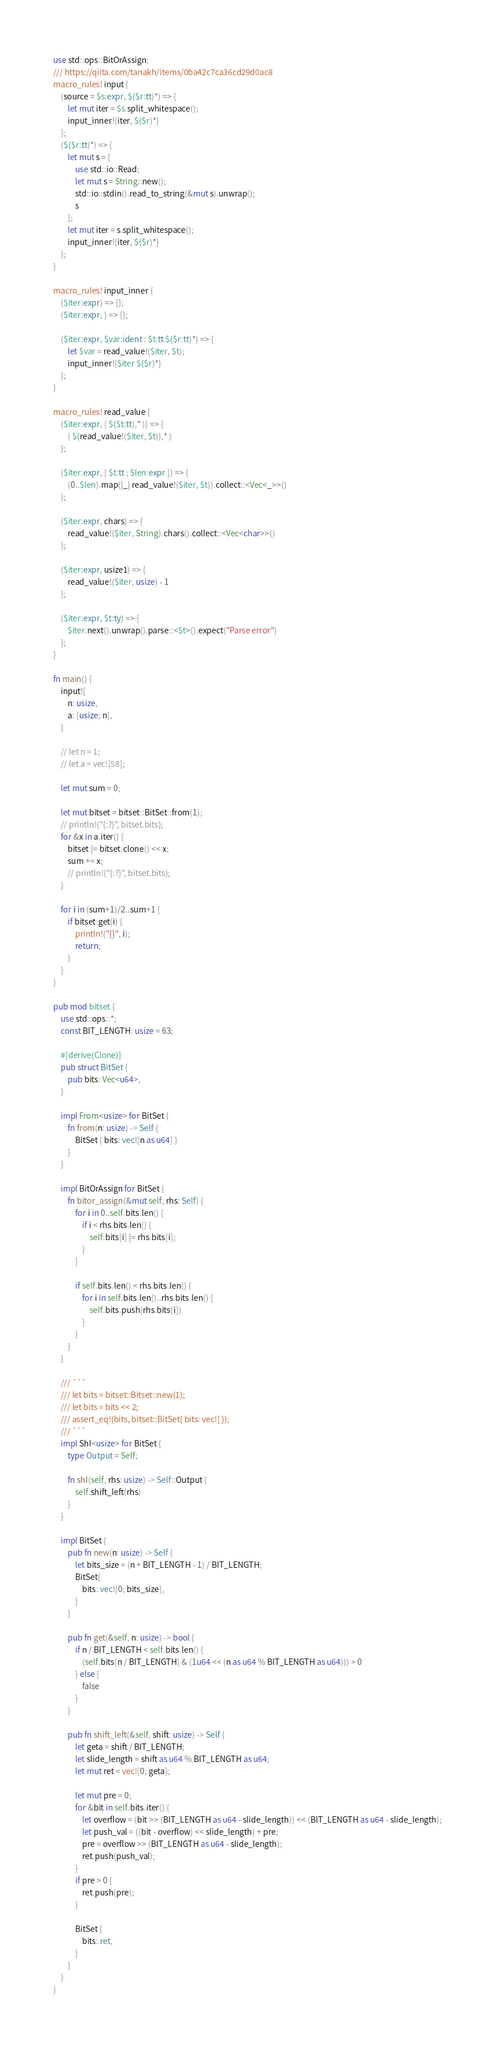<code> <loc_0><loc_0><loc_500><loc_500><_Rust_>use std::ops::BitOrAssign;
/// https://qiita.com/tanakh/items/0ba42c7ca36cd29d0ac8
macro_rules! input {
    (source = $s:expr, $($r:tt)*) => {
        let mut iter = $s.split_whitespace();
        input_inner!{iter, $($r)*}
    };
    ($($r:tt)*) => {
        let mut s = {
            use std::io::Read;
            let mut s = String::new();
            std::io::stdin().read_to_string(&mut s).unwrap();
            s
        };
        let mut iter = s.split_whitespace();
        input_inner!{iter, $($r)*}
    };
}

macro_rules! input_inner {
    ($iter:expr) => {};
    ($iter:expr, ) => {};

    ($iter:expr, $var:ident : $t:tt $($r:tt)*) => {
        let $var = read_value!($iter, $t);
        input_inner!{$iter $($r)*}
    };
}

macro_rules! read_value {
    ($iter:expr, ( $($t:tt),* )) => {
        ( $(read_value!($iter, $t)),* )
    };

    ($iter:expr, [ $t:tt ; $len:expr ]) => {
        (0..$len).map(|_| read_value!($iter, $t)).collect::<Vec<_>>()
    };

    ($iter:expr, chars) => {
        read_value!($iter, String).chars().collect::<Vec<char>>()
    };

    ($iter:expr, usize1) => {
        read_value!($iter, usize) - 1
    };

    ($iter:expr, $t:ty) => {
        $iter.next().unwrap().parse::<$t>().expect("Parse error")
    };
}

fn main() {
    input!{
        n: usize,
        a: [usize; n],
    }

    // let n = 1;
    // let a = vec![58];

    let mut sum = 0;

    let mut bitset = bitset::BitSet::from(1);
    // println!("{:?}", bitset.bits);
    for &x in a.iter() {
        bitset |= bitset.clone() << x;
        sum += x;
        // println!("{:?}", bitset.bits);
    }

    for i in (sum+1)/2..sum+1 {
        if bitset.get(i) {
            println!("{}", i);
            return;
        }
    }
}

pub mod bitset {
    use std::ops::*;
    const BIT_LENGTH: usize = 63;

    #[derive(Clone)]
    pub struct BitSet {
        pub bits: Vec<u64>,
    }

    impl From<usize> for BitSet {
        fn from(n: usize) -> Self {
            BitSet { bits: vec![n as u64] }
        }
    }

    impl BitOrAssign for BitSet {
        fn bitor_assign(&mut self, rhs: Self) {
            for i in 0..self.bits.len() {
                if i < rhs.bits.len() {
                    self.bits[i] |= rhs.bits[i];
                }
            }

            if self.bits.len() < rhs.bits.len() {
                for i in self.bits.len()..rhs.bits.len() {
                    self.bits.push(rhs.bits[i])
                }
            }
        }
    }

    /// ```
    /// let bits = bitset::Bitset::new(1);
    /// let bits = bits << 2;
    /// assert_eq!(bits, bitset::BitSet{ bits: vec![ });
    /// ```
    impl Shl<usize> for BitSet {
        type Output = Self;

        fn shl(self, rhs: usize) -> Self::Output {
            self.shift_left(rhs)
        }
    }

    impl BitSet {
        pub fn new(n: usize) -> Self {
            let bits_size = (n + BIT_LENGTH - 1) / BIT_LENGTH;
            BitSet{
                bits: vec![0; bits_size],
            }
        }

        pub fn get(&self, n: usize) -> bool {
            if n / BIT_LENGTH < self.bits.len() {
                (self.bits[n / BIT_LENGTH] & (1u64 << (n as u64 % BIT_LENGTH as u64))) > 0
            } else {
                false
            }
        }

        pub fn shift_left(&self, shift: usize) -> Self {
            let geta = shift / BIT_LENGTH;
            let slide_length = shift as u64 % BIT_LENGTH as u64;
            let mut ret = vec![0; geta];

            let mut pre = 0;
            for &bit in self.bits.iter() {
                let overflow = (bit >> (BIT_LENGTH as u64 - slide_length)) << (BIT_LENGTH as u64 - slide_length);
                let push_val = ((bit - overflow) << slide_length) + pre;
                pre = overflow >> (BIT_LENGTH as u64 - slide_length);
                ret.push(push_val);
            }
            if pre > 0 {
                ret.push(pre);
            }

            BitSet {
                bits: ret,
            }
        }
    }
}
</code> 